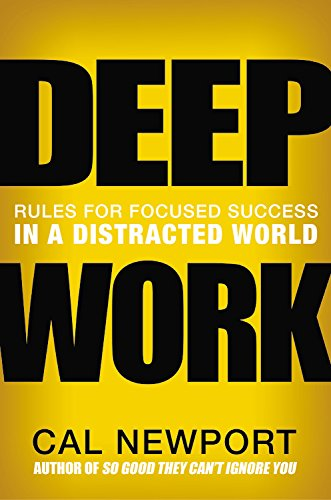What type of book is this? This book is positioned primarily under Business & Money, focusing largely on professional growth and strategies to excel in a distracted world through deep, focused work. 